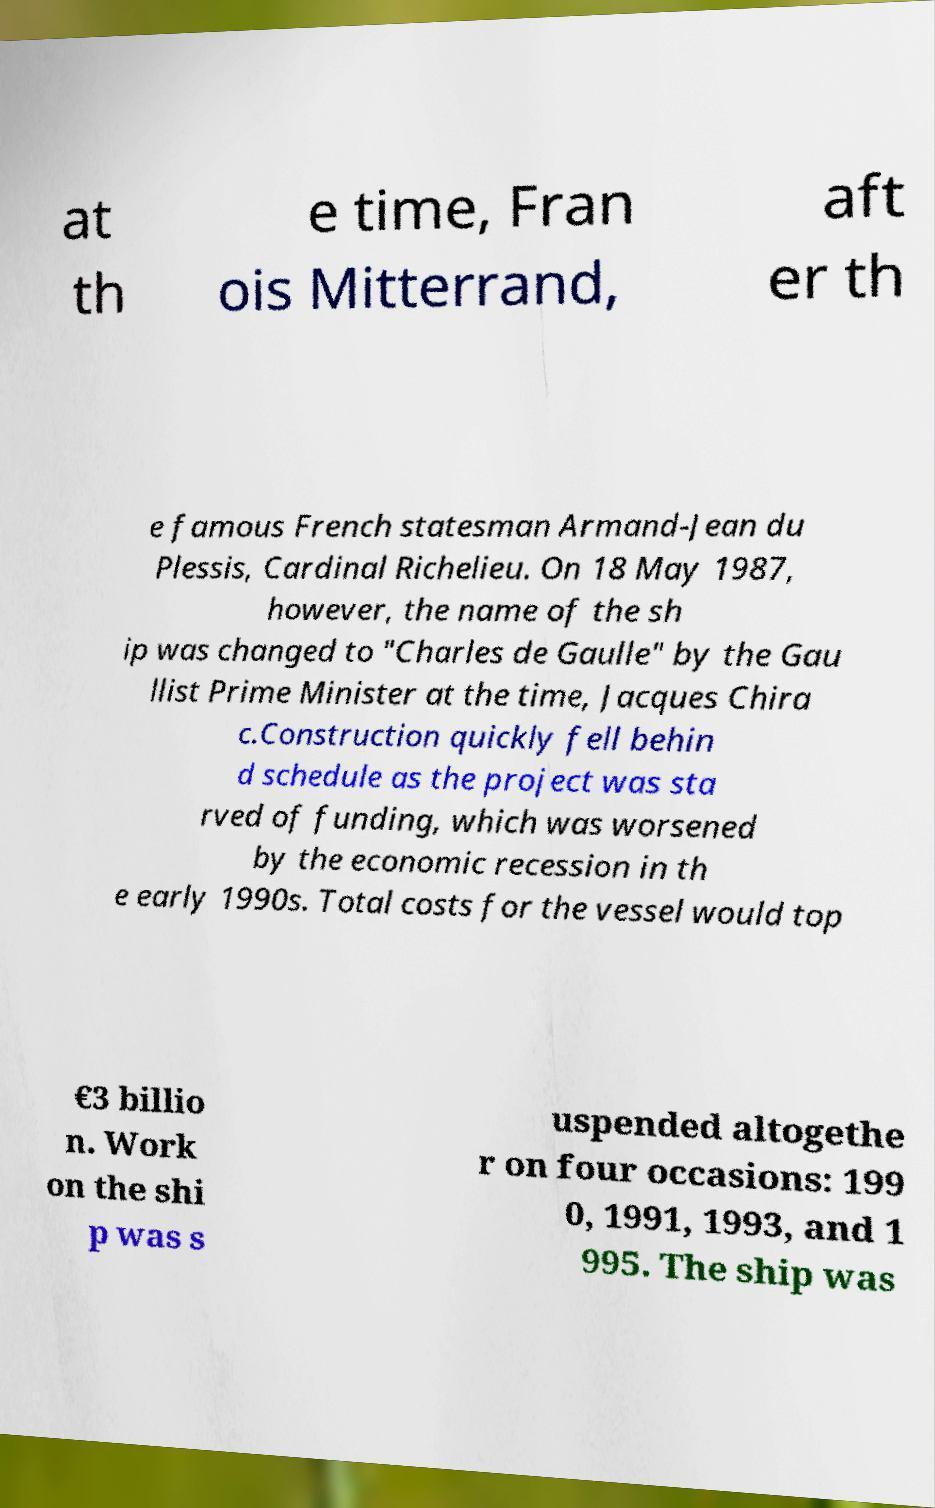Please identify and transcribe the text found in this image. at th e time, Fran ois Mitterrand, aft er th e famous French statesman Armand-Jean du Plessis, Cardinal Richelieu. On 18 May 1987, however, the name of the sh ip was changed to "Charles de Gaulle" by the Gau llist Prime Minister at the time, Jacques Chira c.Construction quickly fell behin d schedule as the project was sta rved of funding, which was worsened by the economic recession in th e early 1990s. Total costs for the vessel would top €3 billio n. Work on the shi p was s uspended altogethe r on four occasions: 199 0, 1991, 1993, and 1 995. The ship was 